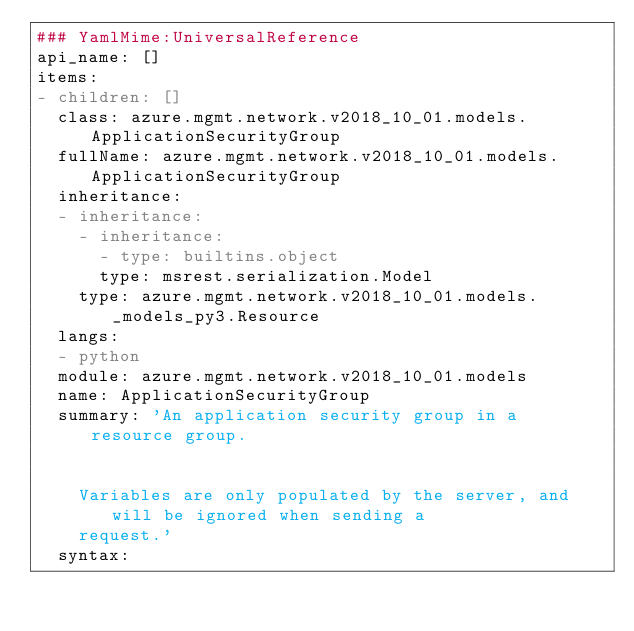Convert code to text. <code><loc_0><loc_0><loc_500><loc_500><_YAML_>### YamlMime:UniversalReference
api_name: []
items:
- children: []
  class: azure.mgmt.network.v2018_10_01.models.ApplicationSecurityGroup
  fullName: azure.mgmt.network.v2018_10_01.models.ApplicationSecurityGroup
  inheritance:
  - inheritance:
    - inheritance:
      - type: builtins.object
      type: msrest.serialization.Model
    type: azure.mgmt.network.v2018_10_01.models._models_py3.Resource
  langs:
  - python
  module: azure.mgmt.network.v2018_10_01.models
  name: ApplicationSecurityGroup
  summary: 'An application security group in a resource group.


    Variables are only populated by the server, and will be ignored when sending a
    request.'
  syntax:</code> 